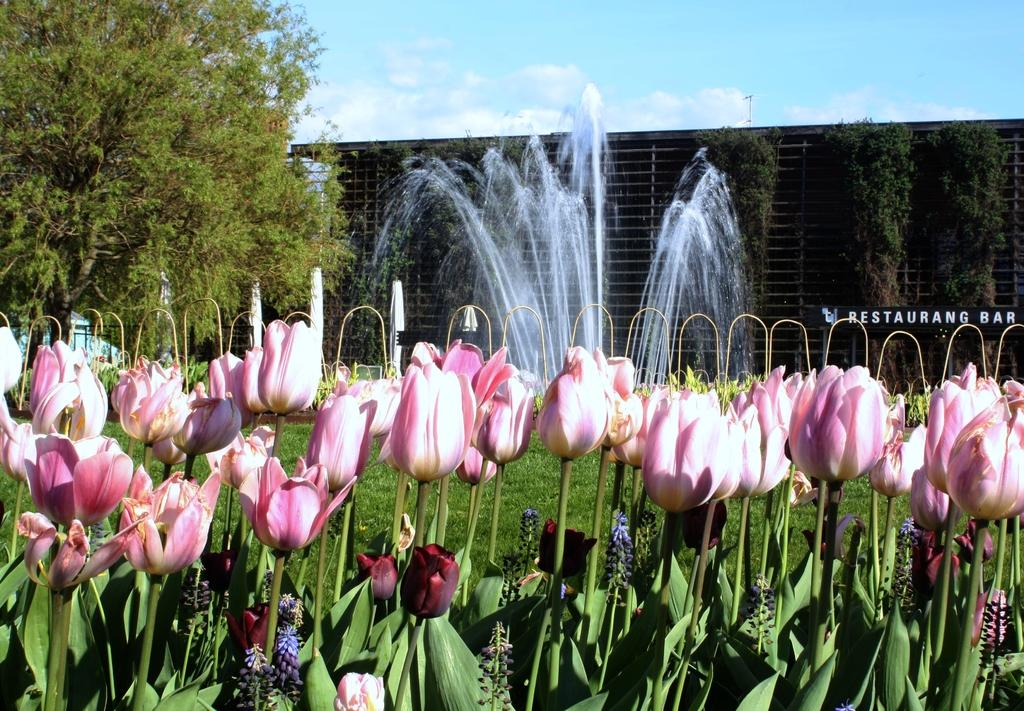What type of plants can be seen in the image? There are flowers in the image. What type of water feature is present in the image? There are water fountains in the image. What type of ground cover is visible in the image? There is grass on the ground in the image. What type of trees are present in the image? There are green trees in the image. What is visible at the top of the image? The sky is visible at the top of the image. How many girls are swimming in the water fountains in the image? There are no girls or swimming activity depicted in the image. Is there a horse grazing on the grass in the image? There is no horse present in the image. 